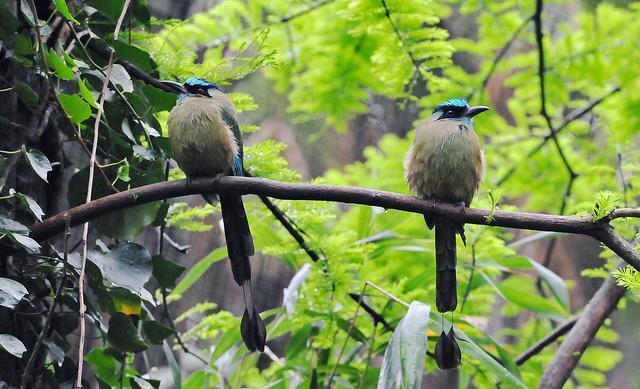How many eyes do you see?
Give a very brief answer. 2. How many birds are in the photo?
Give a very brief answer. 2. How many birds are in the picture?
Give a very brief answer. 2. 